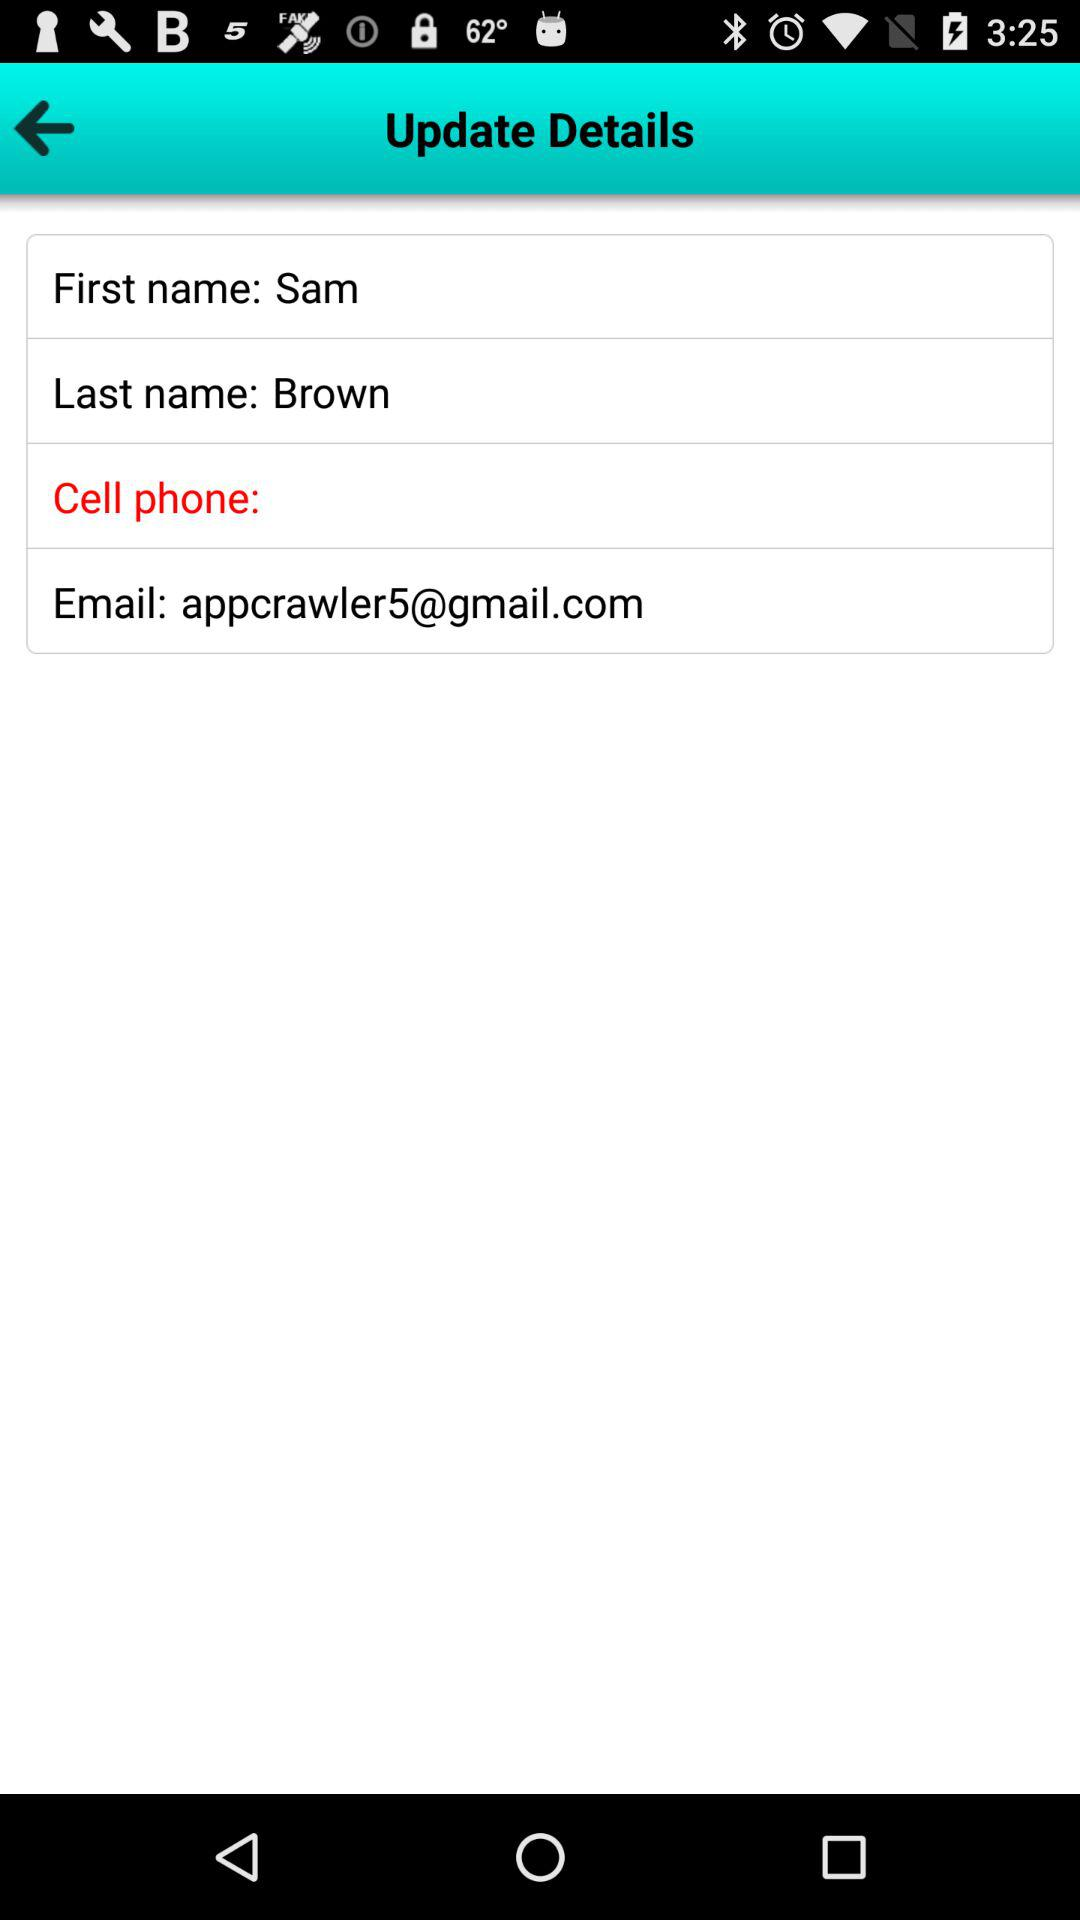What is the email address of the user? The email address is appcrawler5@gmail.com. 